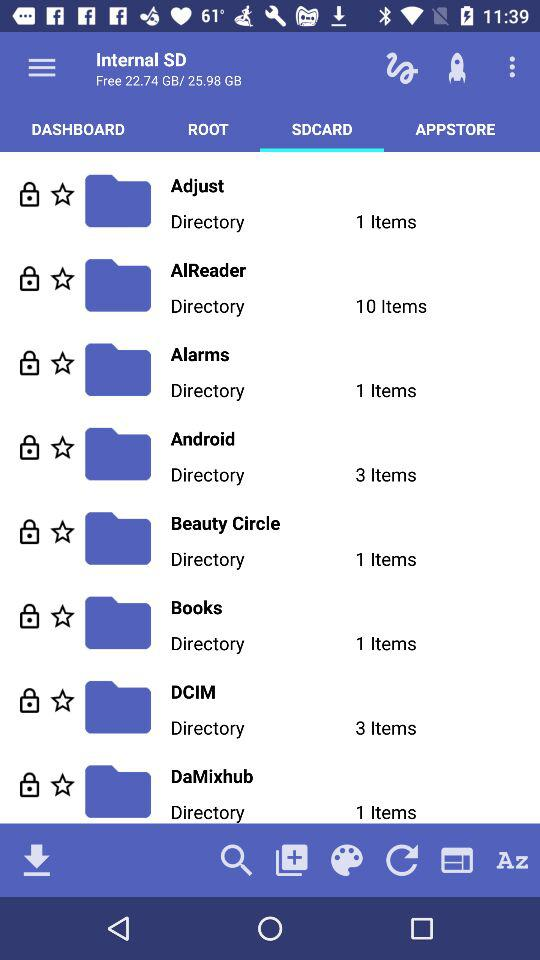Which tab is selected in the internal SD list? The selected tab is "SDCARD". 